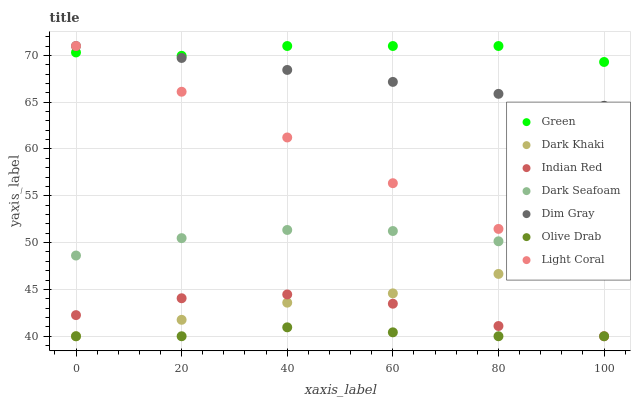Does Olive Drab have the minimum area under the curve?
Answer yes or no. Yes. Does Green have the maximum area under the curve?
Answer yes or no. Yes. Does Dim Gray have the minimum area under the curve?
Answer yes or no. No. Does Dim Gray have the maximum area under the curve?
Answer yes or no. No. Is Light Coral the smoothest?
Answer yes or no. Yes. Is Indian Red the roughest?
Answer yes or no. Yes. Is Dark Khaki the smoothest?
Answer yes or no. No. Is Dark Khaki the roughest?
Answer yes or no. No. Does Dark Khaki have the lowest value?
Answer yes or no. Yes. Does Dim Gray have the lowest value?
Answer yes or no. No. Does Green have the highest value?
Answer yes or no. Yes. Does Dark Khaki have the highest value?
Answer yes or no. No. Is Dark Khaki less than Dim Gray?
Answer yes or no. Yes. Is Green greater than Indian Red?
Answer yes or no. Yes. Does Indian Red intersect Olive Drab?
Answer yes or no. Yes. Is Indian Red less than Olive Drab?
Answer yes or no. No. Is Indian Red greater than Olive Drab?
Answer yes or no. No. Does Dark Khaki intersect Dim Gray?
Answer yes or no. No. 